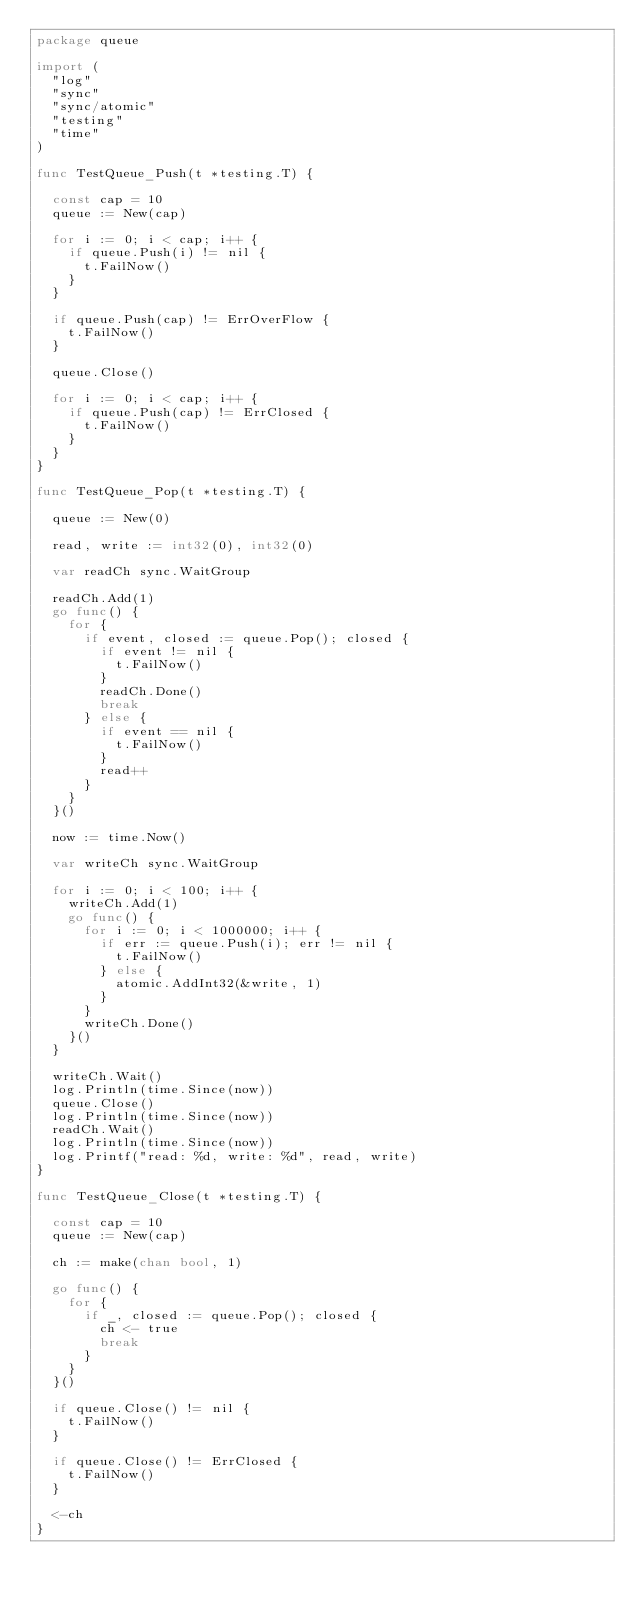Convert code to text. <code><loc_0><loc_0><loc_500><loc_500><_Go_>package queue

import (
	"log"
	"sync"
	"sync/atomic"
	"testing"
	"time"
)

func TestQueue_Push(t *testing.T) {

	const cap = 10
	queue := New(cap)

	for i := 0; i < cap; i++ {
		if queue.Push(i) != nil {
			t.FailNow()
		}
	}

	if queue.Push(cap) != ErrOverFlow {
		t.FailNow()
	}

	queue.Close()

	for i := 0; i < cap; i++ {
		if queue.Push(cap) != ErrClosed {
			t.FailNow()
		}
	}
}

func TestQueue_Pop(t *testing.T) {

	queue := New(0)

	read, write := int32(0), int32(0)

	var readCh sync.WaitGroup

	readCh.Add(1)
	go func() {
		for {
			if event, closed := queue.Pop(); closed {
				if event != nil {
					t.FailNow()
				}
				readCh.Done()
				break
			} else {
				if event == nil {
					t.FailNow()
				}
				read++
			}
		}
	}()

	now := time.Now()

	var writeCh sync.WaitGroup

	for i := 0; i < 100; i++ {
		writeCh.Add(1)
		go func() {
			for i := 0; i < 1000000; i++ {
				if err := queue.Push(i); err != nil {
					t.FailNow()
				} else {
					atomic.AddInt32(&write, 1)
				}
			}
			writeCh.Done()
		}()
	}

	writeCh.Wait()
	log.Println(time.Since(now))
	queue.Close()
	log.Println(time.Since(now))
	readCh.Wait()
	log.Println(time.Since(now))
	log.Printf("read: %d, write: %d", read, write)
}

func TestQueue_Close(t *testing.T) {

	const cap = 10
	queue := New(cap)

	ch := make(chan bool, 1)

	go func() {
		for {
			if _, closed := queue.Pop(); closed {
				ch <- true
				break
			}
		}
	}()

	if queue.Close() != nil {
		t.FailNow()
	}

	if queue.Close() != ErrClosed {
		t.FailNow()
	}

	<-ch
}
</code> 